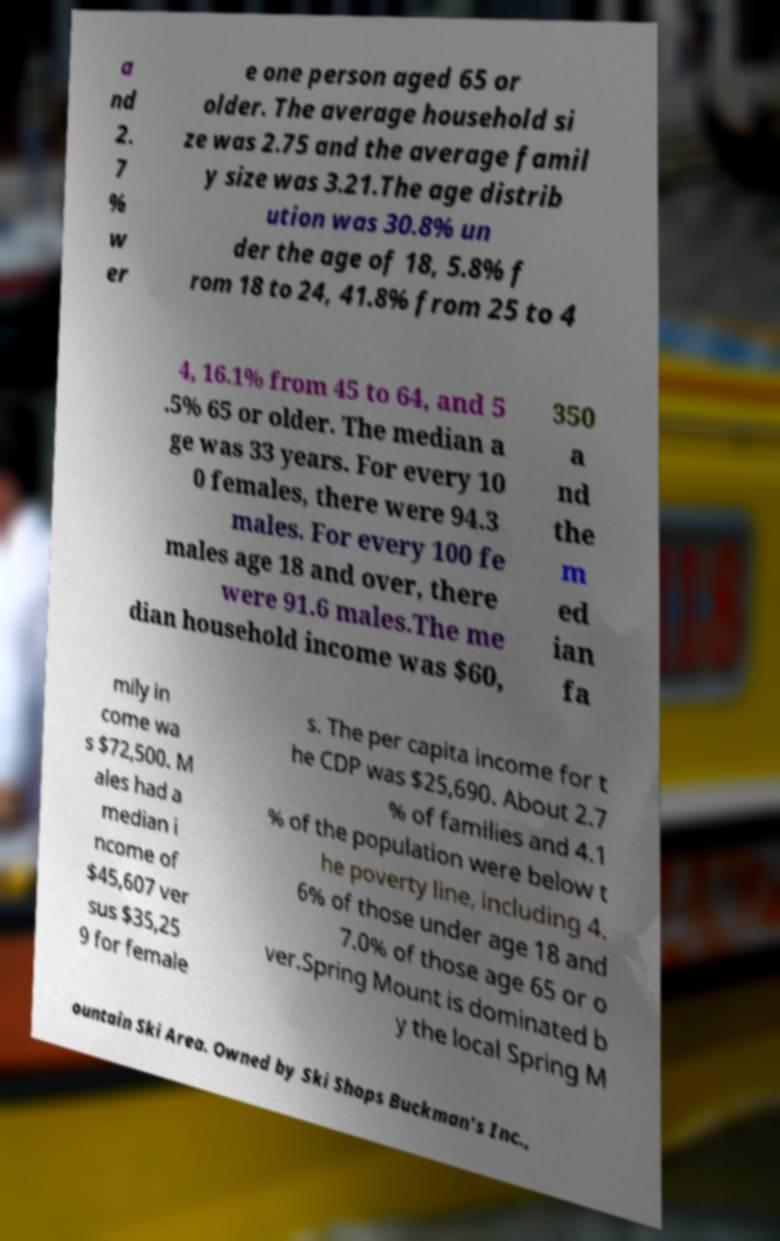Please identify and transcribe the text found in this image. a nd 2. 7 % w er e one person aged 65 or older. The average household si ze was 2.75 and the average famil y size was 3.21.The age distrib ution was 30.8% un der the age of 18, 5.8% f rom 18 to 24, 41.8% from 25 to 4 4, 16.1% from 45 to 64, and 5 .5% 65 or older. The median a ge was 33 years. For every 10 0 females, there were 94.3 males. For every 100 fe males age 18 and over, there were 91.6 males.The me dian household income was $60, 350 a nd the m ed ian fa mily in come wa s $72,500. M ales had a median i ncome of $45,607 ver sus $35,25 9 for female s. The per capita income for t he CDP was $25,690. About 2.7 % of families and 4.1 % of the population were below t he poverty line, including 4. 6% of those under age 18 and 7.0% of those age 65 or o ver.Spring Mount is dominated b y the local Spring M ountain Ski Area. Owned by Ski Shops Buckman's Inc., 